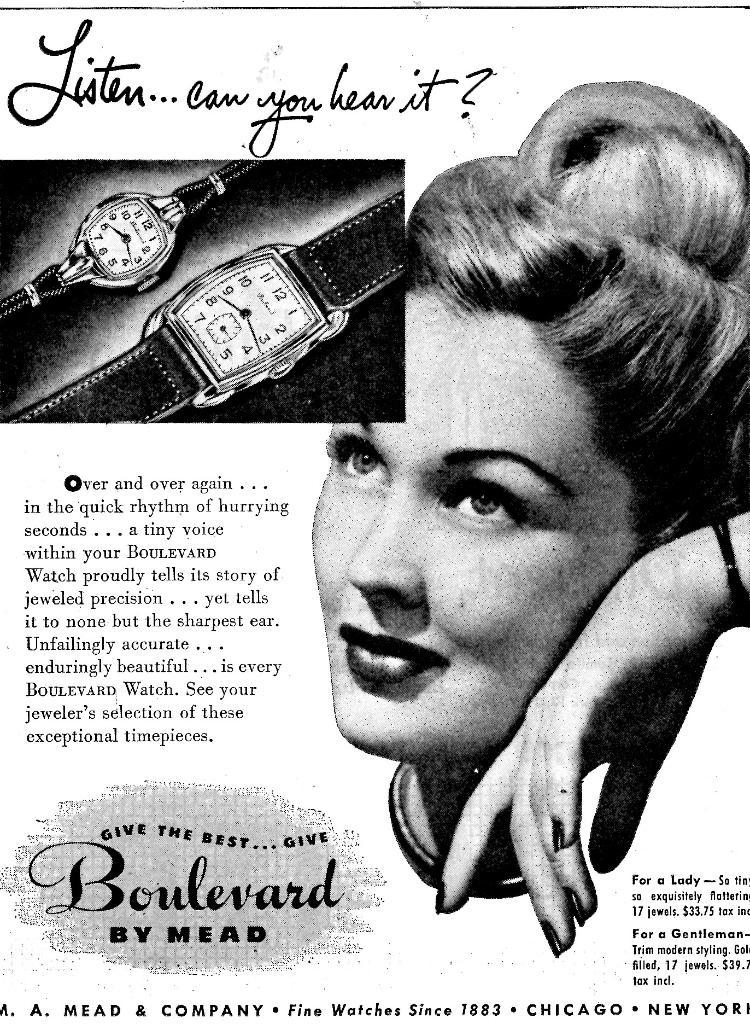<image>
Present a compact description of the photo's key features. A black and white advertisement is displaying an ad for Boulevard Watches by Mead. 